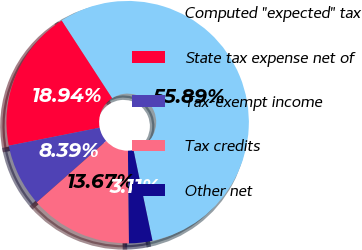<chart> <loc_0><loc_0><loc_500><loc_500><pie_chart><fcel>Computed ''expected'' tax<fcel>State tax expense net of<fcel>Tax-exempt income<fcel>Tax credits<fcel>Other net<nl><fcel>55.88%<fcel>18.94%<fcel>8.39%<fcel>13.67%<fcel>3.11%<nl></chart> 